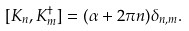Convert formula to latex. <formula><loc_0><loc_0><loc_500><loc_500>[ K _ { n } , K ^ { \dagger } _ { m } ] = ( \alpha + 2 \pi n ) \delta _ { n , m } .</formula> 